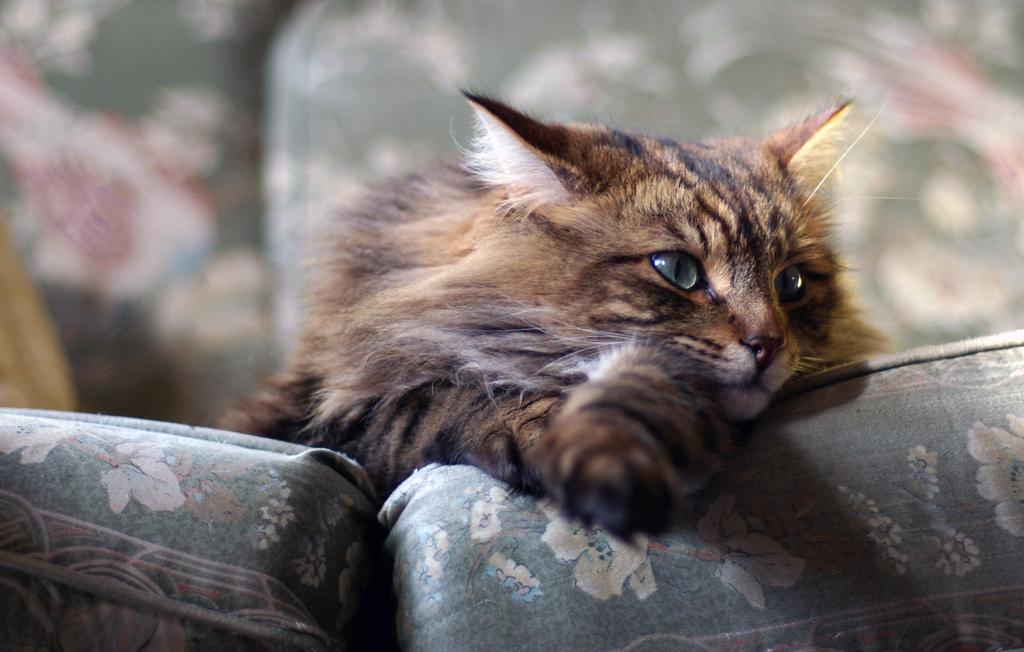What type of animal is in the image? There is a cat in the image. What is the cat doing in the image? The cat is lying on a sofa. Where is the cat positioned in the image? The cat is in the center of the image. Can you see a flock of wrens flying in the image? There is no flock of wrens or any birds visible in the image; it features a cat lying on a sofa. 